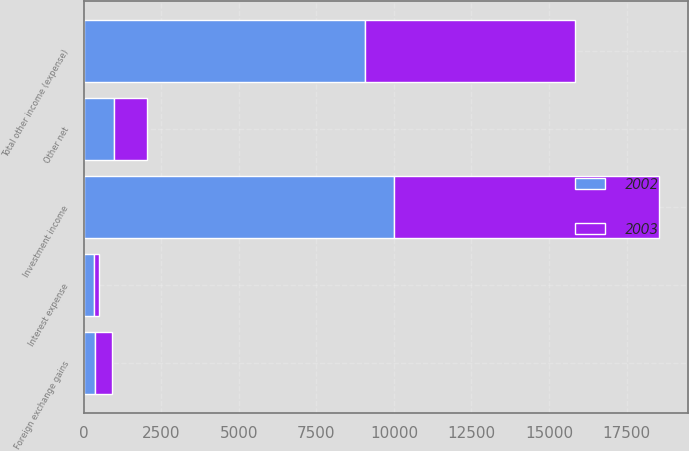Convert chart to OTSL. <chart><loc_0><loc_0><loc_500><loc_500><stacked_bar_chart><ecel><fcel>Investment income<fcel>Interest expense<fcel>Foreign exchange gains<fcel>Other net<fcel>Total other income (expense)<nl><fcel>2003<fcel>8553<fcel>154<fcel>552<fcel>1073<fcel>6774<nl><fcel>2002<fcel>10004<fcel>319<fcel>347<fcel>954<fcel>9078<nl></chart> 